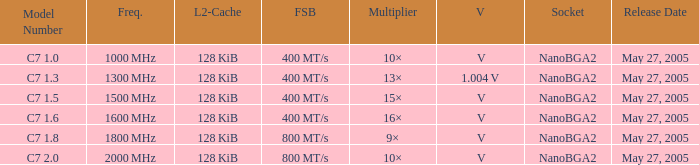What is the Front Side Bus for Model Number c7 1.5? 400 MT/s. 